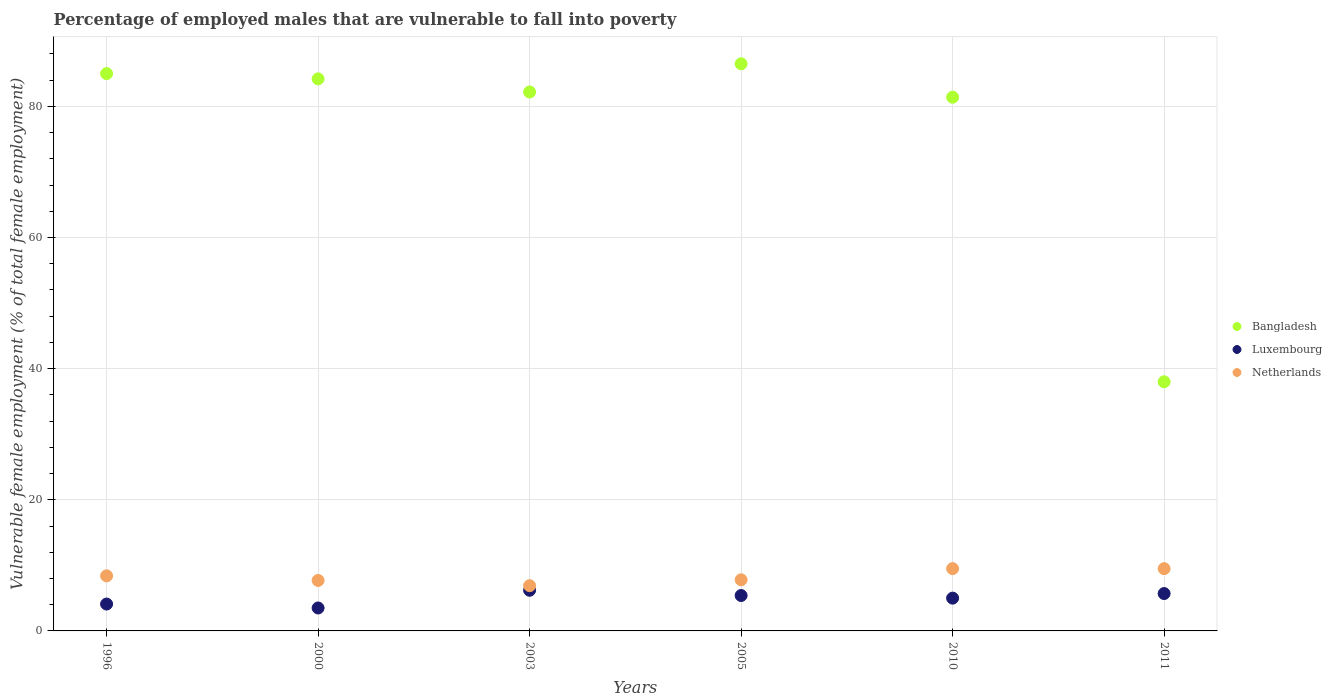How many different coloured dotlines are there?
Make the answer very short. 3. Is the number of dotlines equal to the number of legend labels?
Your response must be concise. Yes. What is the percentage of employed males who are vulnerable to fall into poverty in Bangladesh in 2003?
Your response must be concise. 82.2. Across all years, what is the maximum percentage of employed males who are vulnerable to fall into poverty in Bangladesh?
Keep it short and to the point. 86.5. In which year was the percentage of employed males who are vulnerable to fall into poverty in Luxembourg maximum?
Ensure brevity in your answer.  2003. In which year was the percentage of employed males who are vulnerable to fall into poverty in Netherlands minimum?
Your answer should be very brief. 2003. What is the total percentage of employed males who are vulnerable to fall into poverty in Bangladesh in the graph?
Provide a short and direct response. 457.3. What is the difference between the percentage of employed males who are vulnerable to fall into poverty in Luxembourg in 2000 and that in 2011?
Keep it short and to the point. -2.2. What is the difference between the percentage of employed males who are vulnerable to fall into poverty in Netherlands in 2003 and the percentage of employed males who are vulnerable to fall into poverty in Bangladesh in 2005?
Provide a short and direct response. -79.6. What is the average percentage of employed males who are vulnerable to fall into poverty in Netherlands per year?
Offer a terse response. 8.3. In the year 1996, what is the difference between the percentage of employed males who are vulnerable to fall into poverty in Bangladesh and percentage of employed males who are vulnerable to fall into poverty in Netherlands?
Your answer should be compact. 76.6. What is the ratio of the percentage of employed males who are vulnerable to fall into poverty in Luxembourg in 1996 to that in 2005?
Ensure brevity in your answer.  0.76. Is the percentage of employed males who are vulnerable to fall into poverty in Netherlands in 2005 less than that in 2010?
Provide a short and direct response. Yes. What is the difference between the highest and the second highest percentage of employed males who are vulnerable to fall into poverty in Netherlands?
Ensure brevity in your answer.  0. What is the difference between the highest and the lowest percentage of employed males who are vulnerable to fall into poverty in Netherlands?
Keep it short and to the point. 2.6. Is the sum of the percentage of employed males who are vulnerable to fall into poverty in Netherlands in 2000 and 2003 greater than the maximum percentage of employed males who are vulnerable to fall into poverty in Bangladesh across all years?
Offer a terse response. No. How many years are there in the graph?
Provide a succinct answer. 6. Are the values on the major ticks of Y-axis written in scientific E-notation?
Ensure brevity in your answer.  No. Does the graph contain any zero values?
Keep it short and to the point. No. Does the graph contain grids?
Provide a short and direct response. Yes. How many legend labels are there?
Ensure brevity in your answer.  3. What is the title of the graph?
Your answer should be very brief. Percentage of employed males that are vulnerable to fall into poverty. Does "Malaysia" appear as one of the legend labels in the graph?
Keep it short and to the point. No. What is the label or title of the X-axis?
Give a very brief answer. Years. What is the label or title of the Y-axis?
Your answer should be very brief. Vulnerable female employment (% of total female employment). What is the Vulnerable female employment (% of total female employment) of Bangladesh in 1996?
Your response must be concise. 85. What is the Vulnerable female employment (% of total female employment) of Luxembourg in 1996?
Provide a succinct answer. 4.1. What is the Vulnerable female employment (% of total female employment) of Netherlands in 1996?
Offer a terse response. 8.4. What is the Vulnerable female employment (% of total female employment) in Bangladesh in 2000?
Keep it short and to the point. 84.2. What is the Vulnerable female employment (% of total female employment) in Netherlands in 2000?
Keep it short and to the point. 7.7. What is the Vulnerable female employment (% of total female employment) in Bangladesh in 2003?
Keep it short and to the point. 82.2. What is the Vulnerable female employment (% of total female employment) in Luxembourg in 2003?
Provide a short and direct response. 6.2. What is the Vulnerable female employment (% of total female employment) of Netherlands in 2003?
Ensure brevity in your answer.  6.9. What is the Vulnerable female employment (% of total female employment) of Bangladesh in 2005?
Make the answer very short. 86.5. What is the Vulnerable female employment (% of total female employment) in Luxembourg in 2005?
Your response must be concise. 5.4. What is the Vulnerable female employment (% of total female employment) of Netherlands in 2005?
Ensure brevity in your answer.  7.8. What is the Vulnerable female employment (% of total female employment) of Bangladesh in 2010?
Your answer should be compact. 81.4. What is the Vulnerable female employment (% of total female employment) of Luxembourg in 2011?
Keep it short and to the point. 5.7. Across all years, what is the maximum Vulnerable female employment (% of total female employment) in Bangladesh?
Provide a succinct answer. 86.5. Across all years, what is the maximum Vulnerable female employment (% of total female employment) in Luxembourg?
Provide a succinct answer. 6.2. Across all years, what is the minimum Vulnerable female employment (% of total female employment) in Netherlands?
Provide a short and direct response. 6.9. What is the total Vulnerable female employment (% of total female employment) in Bangladesh in the graph?
Offer a terse response. 457.3. What is the total Vulnerable female employment (% of total female employment) of Luxembourg in the graph?
Ensure brevity in your answer.  29.9. What is the total Vulnerable female employment (% of total female employment) in Netherlands in the graph?
Your answer should be compact. 49.8. What is the difference between the Vulnerable female employment (% of total female employment) of Bangladesh in 1996 and that in 2000?
Offer a very short reply. 0.8. What is the difference between the Vulnerable female employment (% of total female employment) of Luxembourg in 1996 and that in 2000?
Keep it short and to the point. 0.6. What is the difference between the Vulnerable female employment (% of total female employment) in Netherlands in 1996 and that in 2005?
Your answer should be compact. 0.6. What is the difference between the Vulnerable female employment (% of total female employment) in Bangladesh in 1996 and that in 2011?
Offer a very short reply. 47. What is the difference between the Vulnerable female employment (% of total female employment) of Luxembourg in 1996 and that in 2011?
Keep it short and to the point. -1.6. What is the difference between the Vulnerable female employment (% of total female employment) in Netherlands in 1996 and that in 2011?
Give a very brief answer. -1.1. What is the difference between the Vulnerable female employment (% of total female employment) of Bangladesh in 2000 and that in 2003?
Make the answer very short. 2. What is the difference between the Vulnerable female employment (% of total female employment) of Luxembourg in 2000 and that in 2003?
Make the answer very short. -2.7. What is the difference between the Vulnerable female employment (% of total female employment) in Netherlands in 2000 and that in 2003?
Provide a short and direct response. 0.8. What is the difference between the Vulnerable female employment (% of total female employment) of Bangladesh in 2000 and that in 2011?
Make the answer very short. 46.2. What is the difference between the Vulnerable female employment (% of total female employment) of Luxembourg in 2000 and that in 2011?
Offer a terse response. -2.2. What is the difference between the Vulnerable female employment (% of total female employment) in Luxembourg in 2003 and that in 2010?
Provide a succinct answer. 1.2. What is the difference between the Vulnerable female employment (% of total female employment) in Netherlands in 2003 and that in 2010?
Offer a very short reply. -2.6. What is the difference between the Vulnerable female employment (% of total female employment) in Bangladesh in 2003 and that in 2011?
Provide a short and direct response. 44.2. What is the difference between the Vulnerable female employment (% of total female employment) of Luxembourg in 2005 and that in 2010?
Give a very brief answer. 0.4. What is the difference between the Vulnerable female employment (% of total female employment) in Bangladesh in 2005 and that in 2011?
Provide a succinct answer. 48.5. What is the difference between the Vulnerable female employment (% of total female employment) in Luxembourg in 2005 and that in 2011?
Give a very brief answer. -0.3. What is the difference between the Vulnerable female employment (% of total female employment) of Netherlands in 2005 and that in 2011?
Offer a terse response. -1.7. What is the difference between the Vulnerable female employment (% of total female employment) in Bangladesh in 2010 and that in 2011?
Provide a short and direct response. 43.4. What is the difference between the Vulnerable female employment (% of total female employment) of Bangladesh in 1996 and the Vulnerable female employment (% of total female employment) of Luxembourg in 2000?
Offer a very short reply. 81.5. What is the difference between the Vulnerable female employment (% of total female employment) of Bangladesh in 1996 and the Vulnerable female employment (% of total female employment) of Netherlands in 2000?
Keep it short and to the point. 77.3. What is the difference between the Vulnerable female employment (% of total female employment) of Luxembourg in 1996 and the Vulnerable female employment (% of total female employment) of Netherlands in 2000?
Your answer should be very brief. -3.6. What is the difference between the Vulnerable female employment (% of total female employment) in Bangladesh in 1996 and the Vulnerable female employment (% of total female employment) in Luxembourg in 2003?
Ensure brevity in your answer.  78.8. What is the difference between the Vulnerable female employment (% of total female employment) of Bangladesh in 1996 and the Vulnerable female employment (% of total female employment) of Netherlands in 2003?
Make the answer very short. 78.1. What is the difference between the Vulnerable female employment (% of total female employment) of Luxembourg in 1996 and the Vulnerable female employment (% of total female employment) of Netherlands in 2003?
Ensure brevity in your answer.  -2.8. What is the difference between the Vulnerable female employment (% of total female employment) of Bangladesh in 1996 and the Vulnerable female employment (% of total female employment) of Luxembourg in 2005?
Your response must be concise. 79.6. What is the difference between the Vulnerable female employment (% of total female employment) in Bangladesh in 1996 and the Vulnerable female employment (% of total female employment) in Netherlands in 2005?
Provide a short and direct response. 77.2. What is the difference between the Vulnerable female employment (% of total female employment) of Luxembourg in 1996 and the Vulnerable female employment (% of total female employment) of Netherlands in 2005?
Keep it short and to the point. -3.7. What is the difference between the Vulnerable female employment (% of total female employment) in Bangladesh in 1996 and the Vulnerable female employment (% of total female employment) in Netherlands in 2010?
Your response must be concise. 75.5. What is the difference between the Vulnerable female employment (% of total female employment) in Luxembourg in 1996 and the Vulnerable female employment (% of total female employment) in Netherlands in 2010?
Provide a short and direct response. -5.4. What is the difference between the Vulnerable female employment (% of total female employment) of Bangladesh in 1996 and the Vulnerable female employment (% of total female employment) of Luxembourg in 2011?
Make the answer very short. 79.3. What is the difference between the Vulnerable female employment (% of total female employment) of Bangladesh in 1996 and the Vulnerable female employment (% of total female employment) of Netherlands in 2011?
Keep it short and to the point. 75.5. What is the difference between the Vulnerable female employment (% of total female employment) of Luxembourg in 1996 and the Vulnerable female employment (% of total female employment) of Netherlands in 2011?
Provide a short and direct response. -5.4. What is the difference between the Vulnerable female employment (% of total female employment) in Bangladesh in 2000 and the Vulnerable female employment (% of total female employment) in Netherlands in 2003?
Offer a terse response. 77.3. What is the difference between the Vulnerable female employment (% of total female employment) in Luxembourg in 2000 and the Vulnerable female employment (% of total female employment) in Netherlands in 2003?
Offer a terse response. -3.4. What is the difference between the Vulnerable female employment (% of total female employment) of Bangladesh in 2000 and the Vulnerable female employment (% of total female employment) of Luxembourg in 2005?
Keep it short and to the point. 78.8. What is the difference between the Vulnerable female employment (% of total female employment) in Bangladesh in 2000 and the Vulnerable female employment (% of total female employment) in Netherlands in 2005?
Offer a very short reply. 76.4. What is the difference between the Vulnerable female employment (% of total female employment) in Luxembourg in 2000 and the Vulnerable female employment (% of total female employment) in Netherlands in 2005?
Your response must be concise. -4.3. What is the difference between the Vulnerable female employment (% of total female employment) in Bangladesh in 2000 and the Vulnerable female employment (% of total female employment) in Luxembourg in 2010?
Ensure brevity in your answer.  79.2. What is the difference between the Vulnerable female employment (% of total female employment) of Bangladesh in 2000 and the Vulnerable female employment (% of total female employment) of Netherlands in 2010?
Make the answer very short. 74.7. What is the difference between the Vulnerable female employment (% of total female employment) in Luxembourg in 2000 and the Vulnerable female employment (% of total female employment) in Netherlands in 2010?
Provide a short and direct response. -6. What is the difference between the Vulnerable female employment (% of total female employment) in Bangladesh in 2000 and the Vulnerable female employment (% of total female employment) in Luxembourg in 2011?
Your answer should be compact. 78.5. What is the difference between the Vulnerable female employment (% of total female employment) of Bangladesh in 2000 and the Vulnerable female employment (% of total female employment) of Netherlands in 2011?
Give a very brief answer. 74.7. What is the difference between the Vulnerable female employment (% of total female employment) of Luxembourg in 2000 and the Vulnerable female employment (% of total female employment) of Netherlands in 2011?
Provide a short and direct response. -6. What is the difference between the Vulnerable female employment (% of total female employment) in Bangladesh in 2003 and the Vulnerable female employment (% of total female employment) in Luxembourg in 2005?
Your response must be concise. 76.8. What is the difference between the Vulnerable female employment (% of total female employment) in Bangladesh in 2003 and the Vulnerable female employment (% of total female employment) in Netherlands in 2005?
Provide a short and direct response. 74.4. What is the difference between the Vulnerable female employment (% of total female employment) of Luxembourg in 2003 and the Vulnerable female employment (% of total female employment) of Netherlands in 2005?
Ensure brevity in your answer.  -1.6. What is the difference between the Vulnerable female employment (% of total female employment) of Bangladesh in 2003 and the Vulnerable female employment (% of total female employment) of Luxembourg in 2010?
Offer a terse response. 77.2. What is the difference between the Vulnerable female employment (% of total female employment) of Bangladesh in 2003 and the Vulnerable female employment (% of total female employment) of Netherlands in 2010?
Your response must be concise. 72.7. What is the difference between the Vulnerable female employment (% of total female employment) of Bangladesh in 2003 and the Vulnerable female employment (% of total female employment) of Luxembourg in 2011?
Your answer should be compact. 76.5. What is the difference between the Vulnerable female employment (% of total female employment) in Bangladesh in 2003 and the Vulnerable female employment (% of total female employment) in Netherlands in 2011?
Provide a short and direct response. 72.7. What is the difference between the Vulnerable female employment (% of total female employment) of Luxembourg in 2003 and the Vulnerable female employment (% of total female employment) of Netherlands in 2011?
Offer a terse response. -3.3. What is the difference between the Vulnerable female employment (% of total female employment) in Bangladesh in 2005 and the Vulnerable female employment (% of total female employment) in Luxembourg in 2010?
Your answer should be compact. 81.5. What is the difference between the Vulnerable female employment (% of total female employment) in Bangladesh in 2005 and the Vulnerable female employment (% of total female employment) in Netherlands in 2010?
Your answer should be compact. 77. What is the difference between the Vulnerable female employment (% of total female employment) in Bangladesh in 2005 and the Vulnerable female employment (% of total female employment) in Luxembourg in 2011?
Provide a short and direct response. 80.8. What is the difference between the Vulnerable female employment (% of total female employment) in Bangladesh in 2010 and the Vulnerable female employment (% of total female employment) in Luxembourg in 2011?
Make the answer very short. 75.7. What is the difference between the Vulnerable female employment (% of total female employment) of Bangladesh in 2010 and the Vulnerable female employment (% of total female employment) of Netherlands in 2011?
Offer a very short reply. 71.9. What is the difference between the Vulnerable female employment (% of total female employment) of Luxembourg in 2010 and the Vulnerable female employment (% of total female employment) of Netherlands in 2011?
Provide a short and direct response. -4.5. What is the average Vulnerable female employment (% of total female employment) of Bangladesh per year?
Your answer should be very brief. 76.22. What is the average Vulnerable female employment (% of total female employment) of Luxembourg per year?
Your answer should be very brief. 4.98. In the year 1996, what is the difference between the Vulnerable female employment (% of total female employment) in Bangladesh and Vulnerable female employment (% of total female employment) in Luxembourg?
Make the answer very short. 80.9. In the year 1996, what is the difference between the Vulnerable female employment (% of total female employment) of Bangladesh and Vulnerable female employment (% of total female employment) of Netherlands?
Ensure brevity in your answer.  76.6. In the year 1996, what is the difference between the Vulnerable female employment (% of total female employment) in Luxembourg and Vulnerable female employment (% of total female employment) in Netherlands?
Offer a terse response. -4.3. In the year 2000, what is the difference between the Vulnerable female employment (% of total female employment) in Bangladesh and Vulnerable female employment (% of total female employment) in Luxembourg?
Keep it short and to the point. 80.7. In the year 2000, what is the difference between the Vulnerable female employment (% of total female employment) in Bangladesh and Vulnerable female employment (% of total female employment) in Netherlands?
Offer a terse response. 76.5. In the year 2003, what is the difference between the Vulnerable female employment (% of total female employment) in Bangladesh and Vulnerable female employment (% of total female employment) in Netherlands?
Ensure brevity in your answer.  75.3. In the year 2005, what is the difference between the Vulnerable female employment (% of total female employment) in Bangladesh and Vulnerable female employment (% of total female employment) in Luxembourg?
Keep it short and to the point. 81.1. In the year 2005, what is the difference between the Vulnerable female employment (% of total female employment) of Bangladesh and Vulnerable female employment (% of total female employment) of Netherlands?
Offer a terse response. 78.7. In the year 2005, what is the difference between the Vulnerable female employment (% of total female employment) of Luxembourg and Vulnerable female employment (% of total female employment) of Netherlands?
Ensure brevity in your answer.  -2.4. In the year 2010, what is the difference between the Vulnerable female employment (% of total female employment) of Bangladesh and Vulnerable female employment (% of total female employment) of Luxembourg?
Make the answer very short. 76.4. In the year 2010, what is the difference between the Vulnerable female employment (% of total female employment) of Bangladesh and Vulnerable female employment (% of total female employment) of Netherlands?
Keep it short and to the point. 71.9. In the year 2010, what is the difference between the Vulnerable female employment (% of total female employment) of Luxembourg and Vulnerable female employment (% of total female employment) of Netherlands?
Your answer should be very brief. -4.5. In the year 2011, what is the difference between the Vulnerable female employment (% of total female employment) of Bangladesh and Vulnerable female employment (% of total female employment) of Luxembourg?
Make the answer very short. 32.3. What is the ratio of the Vulnerable female employment (% of total female employment) in Bangladesh in 1996 to that in 2000?
Your answer should be compact. 1.01. What is the ratio of the Vulnerable female employment (% of total female employment) in Luxembourg in 1996 to that in 2000?
Keep it short and to the point. 1.17. What is the ratio of the Vulnerable female employment (% of total female employment) of Netherlands in 1996 to that in 2000?
Ensure brevity in your answer.  1.09. What is the ratio of the Vulnerable female employment (% of total female employment) of Bangladesh in 1996 to that in 2003?
Offer a terse response. 1.03. What is the ratio of the Vulnerable female employment (% of total female employment) of Luxembourg in 1996 to that in 2003?
Offer a very short reply. 0.66. What is the ratio of the Vulnerable female employment (% of total female employment) of Netherlands in 1996 to that in 2003?
Provide a succinct answer. 1.22. What is the ratio of the Vulnerable female employment (% of total female employment) in Bangladesh in 1996 to that in 2005?
Provide a short and direct response. 0.98. What is the ratio of the Vulnerable female employment (% of total female employment) of Luxembourg in 1996 to that in 2005?
Your answer should be compact. 0.76. What is the ratio of the Vulnerable female employment (% of total female employment) in Netherlands in 1996 to that in 2005?
Your answer should be compact. 1.08. What is the ratio of the Vulnerable female employment (% of total female employment) of Bangladesh in 1996 to that in 2010?
Your response must be concise. 1.04. What is the ratio of the Vulnerable female employment (% of total female employment) of Luxembourg in 1996 to that in 2010?
Keep it short and to the point. 0.82. What is the ratio of the Vulnerable female employment (% of total female employment) of Netherlands in 1996 to that in 2010?
Your response must be concise. 0.88. What is the ratio of the Vulnerable female employment (% of total female employment) of Bangladesh in 1996 to that in 2011?
Provide a short and direct response. 2.24. What is the ratio of the Vulnerable female employment (% of total female employment) of Luxembourg in 1996 to that in 2011?
Make the answer very short. 0.72. What is the ratio of the Vulnerable female employment (% of total female employment) in Netherlands in 1996 to that in 2011?
Provide a succinct answer. 0.88. What is the ratio of the Vulnerable female employment (% of total female employment) of Bangladesh in 2000 to that in 2003?
Keep it short and to the point. 1.02. What is the ratio of the Vulnerable female employment (% of total female employment) of Luxembourg in 2000 to that in 2003?
Provide a succinct answer. 0.56. What is the ratio of the Vulnerable female employment (% of total female employment) of Netherlands in 2000 to that in 2003?
Make the answer very short. 1.12. What is the ratio of the Vulnerable female employment (% of total female employment) in Bangladesh in 2000 to that in 2005?
Make the answer very short. 0.97. What is the ratio of the Vulnerable female employment (% of total female employment) in Luxembourg in 2000 to that in 2005?
Offer a very short reply. 0.65. What is the ratio of the Vulnerable female employment (% of total female employment) in Netherlands in 2000 to that in 2005?
Keep it short and to the point. 0.99. What is the ratio of the Vulnerable female employment (% of total female employment) of Bangladesh in 2000 to that in 2010?
Keep it short and to the point. 1.03. What is the ratio of the Vulnerable female employment (% of total female employment) of Luxembourg in 2000 to that in 2010?
Ensure brevity in your answer.  0.7. What is the ratio of the Vulnerable female employment (% of total female employment) in Netherlands in 2000 to that in 2010?
Offer a terse response. 0.81. What is the ratio of the Vulnerable female employment (% of total female employment) in Bangladesh in 2000 to that in 2011?
Provide a succinct answer. 2.22. What is the ratio of the Vulnerable female employment (% of total female employment) in Luxembourg in 2000 to that in 2011?
Ensure brevity in your answer.  0.61. What is the ratio of the Vulnerable female employment (% of total female employment) of Netherlands in 2000 to that in 2011?
Your response must be concise. 0.81. What is the ratio of the Vulnerable female employment (% of total female employment) of Bangladesh in 2003 to that in 2005?
Your answer should be very brief. 0.95. What is the ratio of the Vulnerable female employment (% of total female employment) in Luxembourg in 2003 to that in 2005?
Your answer should be compact. 1.15. What is the ratio of the Vulnerable female employment (% of total female employment) of Netherlands in 2003 to that in 2005?
Offer a terse response. 0.88. What is the ratio of the Vulnerable female employment (% of total female employment) of Bangladesh in 2003 to that in 2010?
Make the answer very short. 1.01. What is the ratio of the Vulnerable female employment (% of total female employment) in Luxembourg in 2003 to that in 2010?
Provide a succinct answer. 1.24. What is the ratio of the Vulnerable female employment (% of total female employment) of Netherlands in 2003 to that in 2010?
Your response must be concise. 0.73. What is the ratio of the Vulnerable female employment (% of total female employment) of Bangladesh in 2003 to that in 2011?
Keep it short and to the point. 2.16. What is the ratio of the Vulnerable female employment (% of total female employment) of Luxembourg in 2003 to that in 2011?
Keep it short and to the point. 1.09. What is the ratio of the Vulnerable female employment (% of total female employment) in Netherlands in 2003 to that in 2011?
Your answer should be very brief. 0.73. What is the ratio of the Vulnerable female employment (% of total female employment) in Bangladesh in 2005 to that in 2010?
Give a very brief answer. 1.06. What is the ratio of the Vulnerable female employment (% of total female employment) in Luxembourg in 2005 to that in 2010?
Offer a very short reply. 1.08. What is the ratio of the Vulnerable female employment (% of total female employment) of Netherlands in 2005 to that in 2010?
Make the answer very short. 0.82. What is the ratio of the Vulnerable female employment (% of total female employment) of Bangladesh in 2005 to that in 2011?
Make the answer very short. 2.28. What is the ratio of the Vulnerable female employment (% of total female employment) of Luxembourg in 2005 to that in 2011?
Your answer should be compact. 0.95. What is the ratio of the Vulnerable female employment (% of total female employment) in Netherlands in 2005 to that in 2011?
Make the answer very short. 0.82. What is the ratio of the Vulnerable female employment (% of total female employment) in Bangladesh in 2010 to that in 2011?
Provide a succinct answer. 2.14. What is the ratio of the Vulnerable female employment (% of total female employment) of Luxembourg in 2010 to that in 2011?
Keep it short and to the point. 0.88. What is the ratio of the Vulnerable female employment (% of total female employment) in Netherlands in 2010 to that in 2011?
Your response must be concise. 1. What is the difference between the highest and the second highest Vulnerable female employment (% of total female employment) in Luxembourg?
Offer a very short reply. 0.5. What is the difference between the highest and the lowest Vulnerable female employment (% of total female employment) in Bangladesh?
Ensure brevity in your answer.  48.5. What is the difference between the highest and the lowest Vulnerable female employment (% of total female employment) of Luxembourg?
Ensure brevity in your answer.  2.7. What is the difference between the highest and the lowest Vulnerable female employment (% of total female employment) in Netherlands?
Offer a terse response. 2.6. 